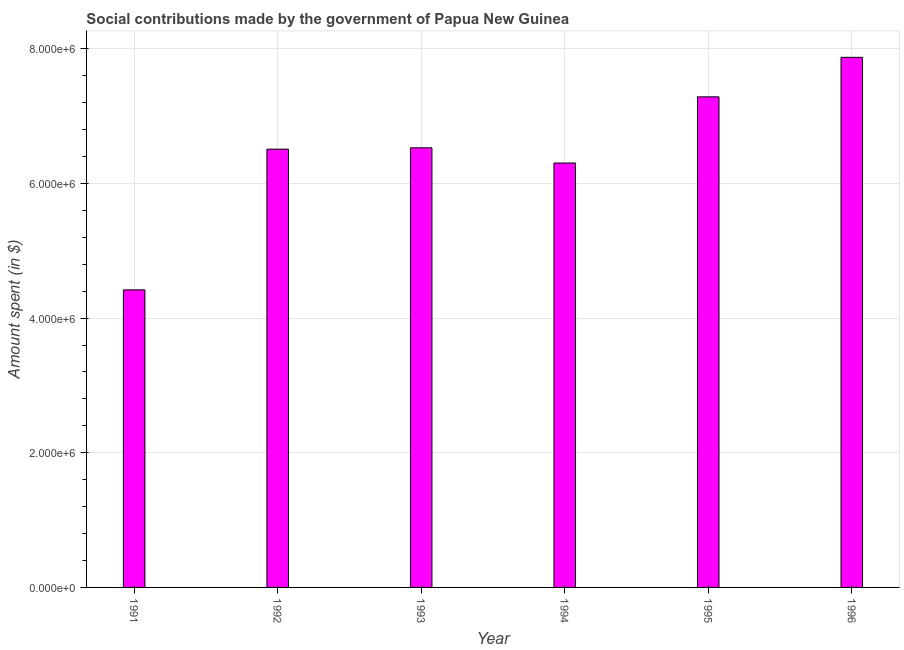Does the graph contain any zero values?
Offer a very short reply. No. What is the title of the graph?
Your answer should be compact. Social contributions made by the government of Papua New Guinea. What is the label or title of the Y-axis?
Provide a short and direct response. Amount spent (in $). What is the amount spent in making social contributions in 1993?
Offer a terse response. 6.53e+06. Across all years, what is the maximum amount spent in making social contributions?
Give a very brief answer. 7.87e+06. Across all years, what is the minimum amount spent in making social contributions?
Keep it short and to the point. 4.42e+06. In which year was the amount spent in making social contributions maximum?
Offer a terse response. 1996. What is the sum of the amount spent in making social contributions?
Make the answer very short. 3.89e+07. What is the difference between the amount spent in making social contributions in 1992 and 1995?
Your response must be concise. -7.77e+05. What is the average amount spent in making social contributions per year?
Your answer should be compact. 6.49e+06. What is the median amount spent in making social contributions?
Your answer should be compact. 6.52e+06. Do a majority of the years between 1992 and 1996 (inclusive) have amount spent in making social contributions greater than 5600000 $?
Provide a short and direct response. Yes. What is the ratio of the amount spent in making social contributions in 1992 to that in 1994?
Your answer should be compact. 1.03. Is the difference between the amount spent in making social contributions in 1994 and 1995 greater than the difference between any two years?
Provide a short and direct response. No. What is the difference between the highest and the second highest amount spent in making social contributions?
Provide a short and direct response. 5.87e+05. What is the difference between the highest and the lowest amount spent in making social contributions?
Provide a succinct answer. 3.45e+06. In how many years, is the amount spent in making social contributions greater than the average amount spent in making social contributions taken over all years?
Your answer should be compact. 4. How many bars are there?
Provide a succinct answer. 6. What is the difference between two consecutive major ticks on the Y-axis?
Make the answer very short. 2.00e+06. Are the values on the major ticks of Y-axis written in scientific E-notation?
Provide a succinct answer. Yes. What is the Amount spent (in $) in 1991?
Offer a very short reply. 4.42e+06. What is the Amount spent (in $) in 1992?
Provide a succinct answer. 6.51e+06. What is the Amount spent (in $) in 1993?
Offer a terse response. 6.53e+06. What is the Amount spent (in $) of 1994?
Offer a very short reply. 6.30e+06. What is the Amount spent (in $) of 1995?
Provide a succinct answer. 7.29e+06. What is the Amount spent (in $) of 1996?
Your response must be concise. 7.87e+06. What is the difference between the Amount spent (in $) in 1991 and 1992?
Keep it short and to the point. -2.09e+06. What is the difference between the Amount spent (in $) in 1991 and 1993?
Give a very brief answer. -2.11e+06. What is the difference between the Amount spent (in $) in 1991 and 1994?
Give a very brief answer. -1.88e+06. What is the difference between the Amount spent (in $) in 1991 and 1995?
Offer a very short reply. -2.87e+06. What is the difference between the Amount spent (in $) in 1991 and 1996?
Offer a terse response. -3.45e+06. What is the difference between the Amount spent (in $) in 1992 and 1993?
Your answer should be compact. -2.00e+04. What is the difference between the Amount spent (in $) in 1992 and 1994?
Your answer should be compact. 2.06e+05. What is the difference between the Amount spent (in $) in 1992 and 1995?
Provide a succinct answer. -7.77e+05. What is the difference between the Amount spent (in $) in 1992 and 1996?
Give a very brief answer. -1.36e+06. What is the difference between the Amount spent (in $) in 1993 and 1994?
Provide a succinct answer. 2.26e+05. What is the difference between the Amount spent (in $) in 1993 and 1995?
Offer a very short reply. -7.57e+05. What is the difference between the Amount spent (in $) in 1993 and 1996?
Your answer should be compact. -1.34e+06. What is the difference between the Amount spent (in $) in 1994 and 1995?
Your response must be concise. -9.83e+05. What is the difference between the Amount spent (in $) in 1994 and 1996?
Offer a terse response. -1.57e+06. What is the difference between the Amount spent (in $) in 1995 and 1996?
Provide a succinct answer. -5.87e+05. What is the ratio of the Amount spent (in $) in 1991 to that in 1992?
Provide a succinct answer. 0.68. What is the ratio of the Amount spent (in $) in 1991 to that in 1993?
Your answer should be very brief. 0.68. What is the ratio of the Amount spent (in $) in 1991 to that in 1994?
Keep it short and to the point. 0.7. What is the ratio of the Amount spent (in $) in 1991 to that in 1995?
Make the answer very short. 0.61. What is the ratio of the Amount spent (in $) in 1991 to that in 1996?
Ensure brevity in your answer.  0.56. What is the ratio of the Amount spent (in $) in 1992 to that in 1993?
Provide a succinct answer. 1. What is the ratio of the Amount spent (in $) in 1992 to that in 1994?
Provide a short and direct response. 1.03. What is the ratio of the Amount spent (in $) in 1992 to that in 1995?
Ensure brevity in your answer.  0.89. What is the ratio of the Amount spent (in $) in 1992 to that in 1996?
Offer a very short reply. 0.83. What is the ratio of the Amount spent (in $) in 1993 to that in 1994?
Ensure brevity in your answer.  1.04. What is the ratio of the Amount spent (in $) in 1993 to that in 1995?
Give a very brief answer. 0.9. What is the ratio of the Amount spent (in $) in 1993 to that in 1996?
Offer a very short reply. 0.83. What is the ratio of the Amount spent (in $) in 1994 to that in 1995?
Keep it short and to the point. 0.86. What is the ratio of the Amount spent (in $) in 1994 to that in 1996?
Your answer should be compact. 0.8. What is the ratio of the Amount spent (in $) in 1995 to that in 1996?
Offer a very short reply. 0.93. 